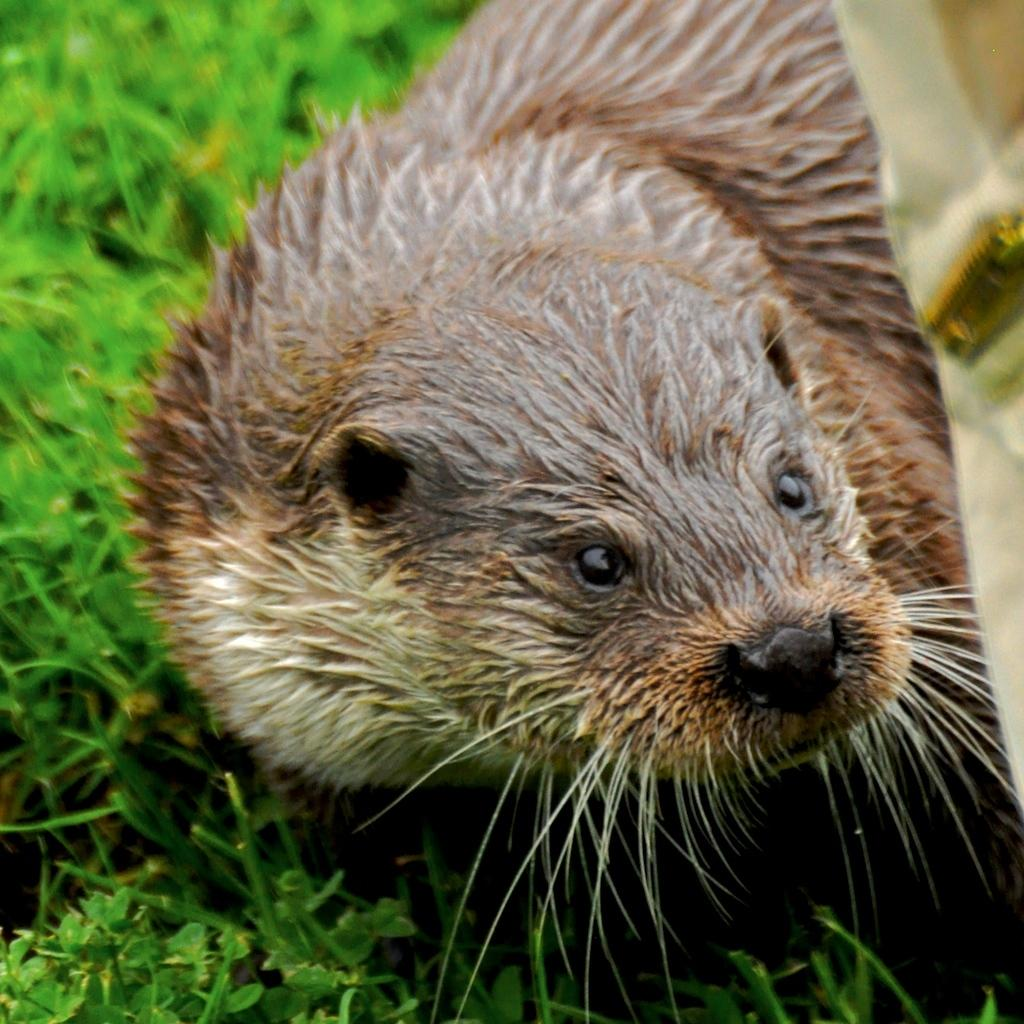What animal is present in the image? There is an otter in the image. What is the color of the otter? The otter is brown in color. What type of vegetation can be seen at the bottom of the image? There is green grass at the bottom of the image. How many cakes are on the bed in the image? There is no bed or cakes present in the image; it features an otter and green grass. 